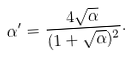Convert formula to latex. <formula><loc_0><loc_0><loc_500><loc_500>\alpha ^ { \prime } = \frac { 4 \sqrt { \alpha } } { ( 1 + \sqrt { \alpha } ) ^ { 2 } } .</formula> 